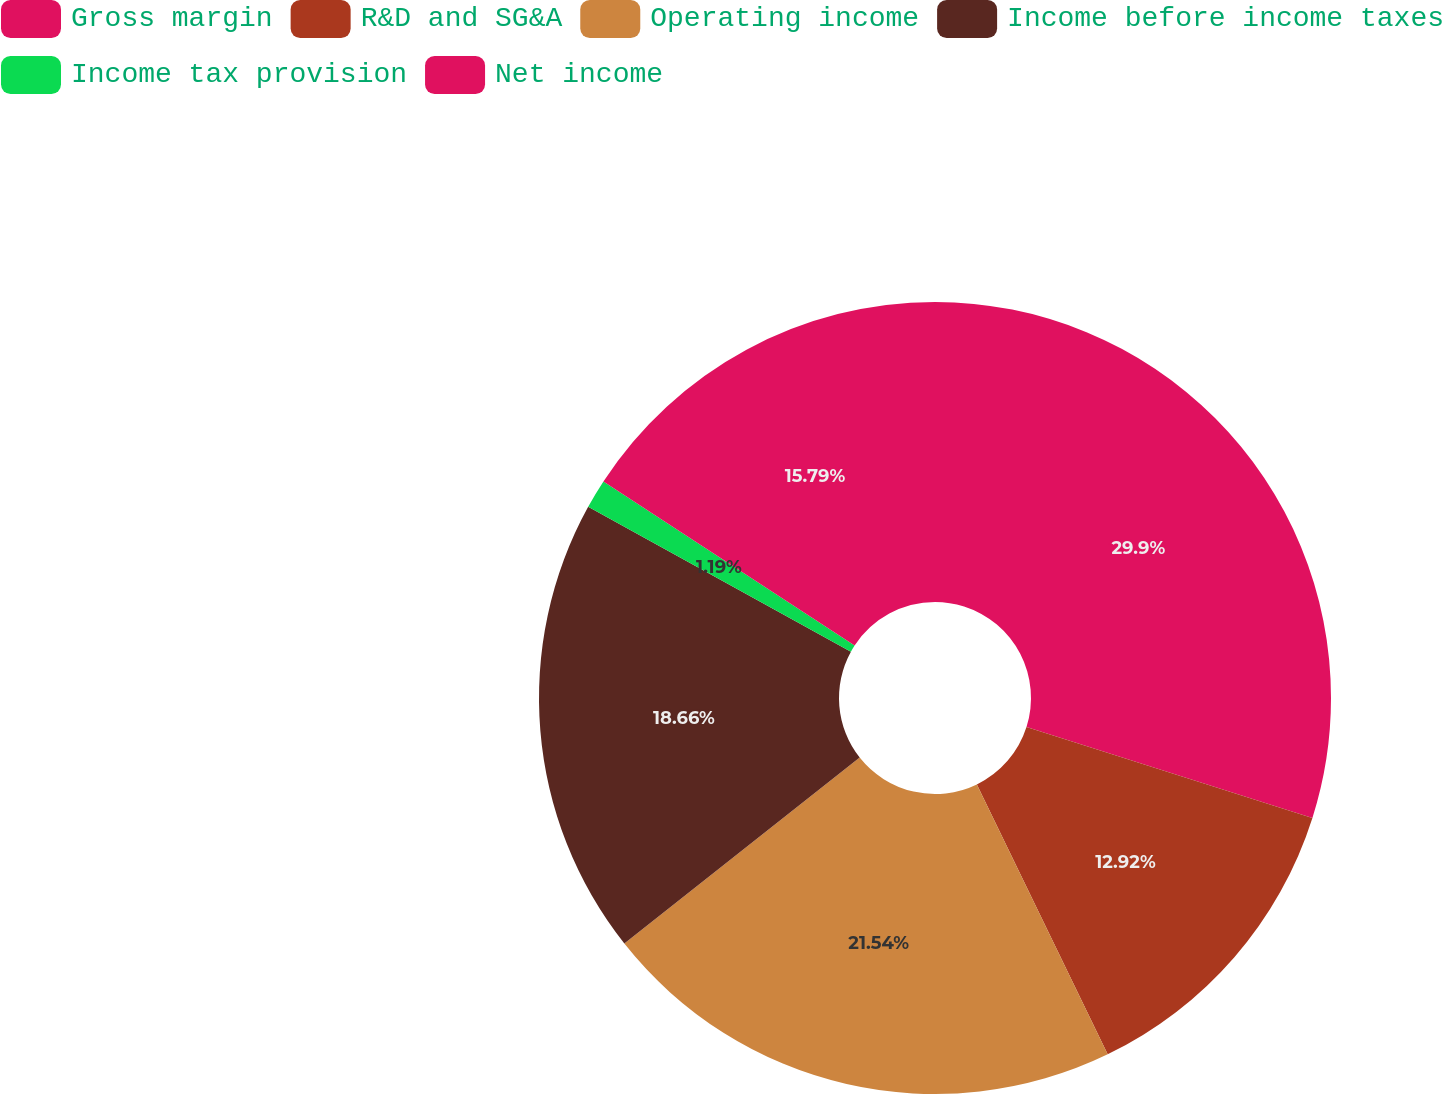<chart> <loc_0><loc_0><loc_500><loc_500><pie_chart><fcel>Gross margin<fcel>R&D and SG&A<fcel>Operating income<fcel>Income before income taxes<fcel>Income tax provision<fcel>Net income<nl><fcel>29.89%<fcel>12.92%<fcel>21.53%<fcel>18.66%<fcel>1.19%<fcel>15.79%<nl></chart> 